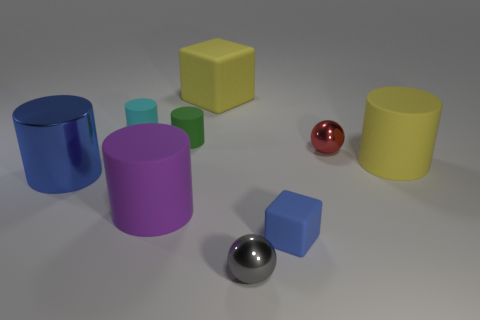What is the size of the object that is both to the right of the small gray thing and in front of the large purple thing?
Keep it short and to the point. Small. What number of metal objects are big purple things or small blocks?
Your answer should be compact. 0. There is a large yellow thing that is in front of the cyan matte cylinder; does it have the same shape as the tiny blue rubber object that is behind the tiny gray metallic thing?
Your answer should be compact. No. Is there a small cylinder made of the same material as the big purple cylinder?
Keep it short and to the point. Yes. The small matte block is what color?
Make the answer very short. Blue. There is a cube that is behind the big blue metal cylinder; what size is it?
Offer a terse response. Large. How many other large cylinders are the same color as the large shiny cylinder?
Your answer should be compact. 0. Are there any big blue shiny cylinders right of the rubber block behind the small red metallic sphere?
Provide a short and direct response. No. There is a thing that is on the right side of the red metallic ball; is its color the same as the small shiny ball in front of the big blue object?
Keep it short and to the point. No. There is a cube that is the same size as the red metal object; what color is it?
Offer a very short reply. Blue. 